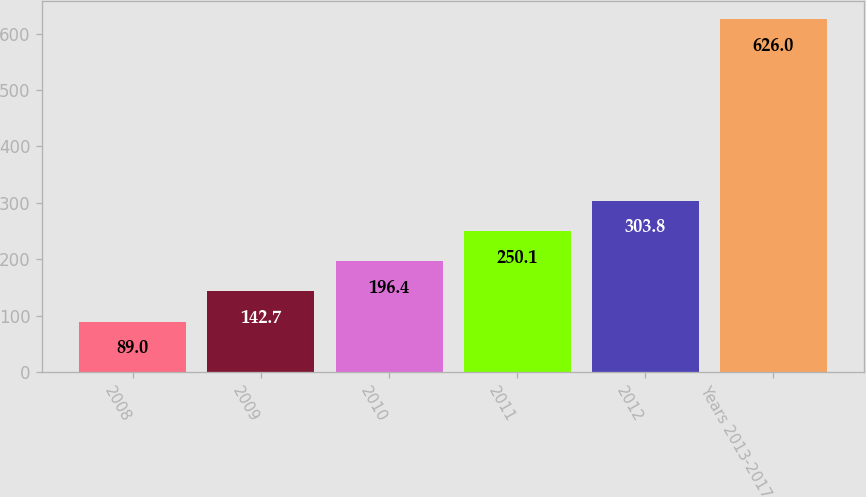Convert chart. <chart><loc_0><loc_0><loc_500><loc_500><bar_chart><fcel>2008<fcel>2009<fcel>2010<fcel>2011<fcel>2012<fcel>Years 2013-2017<nl><fcel>89<fcel>142.7<fcel>196.4<fcel>250.1<fcel>303.8<fcel>626<nl></chart> 